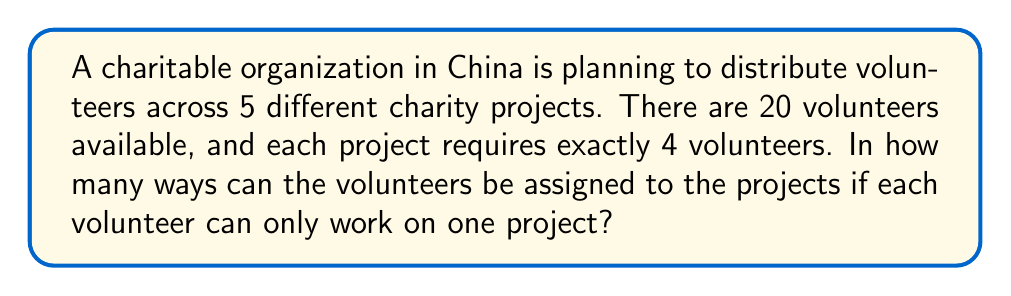Can you answer this question? Let's approach this step-by-step:

1) This is a partition problem, where we need to divide 20 volunteers into 5 groups of 4.

2) The number of ways to do this is given by the multinomial coefficient:

   $$\binom{20}{4,4,4,4,4}$$

3) The formula for this multinomial coefficient is:

   $$\frac{20!}{4!4!4!4!4!}$$

4) Let's calculate this:
   
   $$\frac{20!}{(4!)^5}$$

5) Expand this:
   
   $$\frac{20 \cdot 19 \cdot 18 \cdot 17 \cdot 16 \cdot 15 \cdot 14 \cdot 13 \cdot 12 \cdot 11 \cdot 10 \cdot 9 \cdot 8 \cdot 7 \cdot 6 \cdot 5 \cdot 4 \cdot 3 \cdot 2 \cdot 1}{(4 \cdot 3 \cdot 2 \cdot 1)^5}$$

6) Calculate:
   
   $$\frac{2432902008176640000}{1024 \cdot 1024} = 2,309,350,744,400$$

Therefore, there are 2,309,350,744,400 ways to assign the volunteers to the projects.
Answer: 2,309,350,744,400 